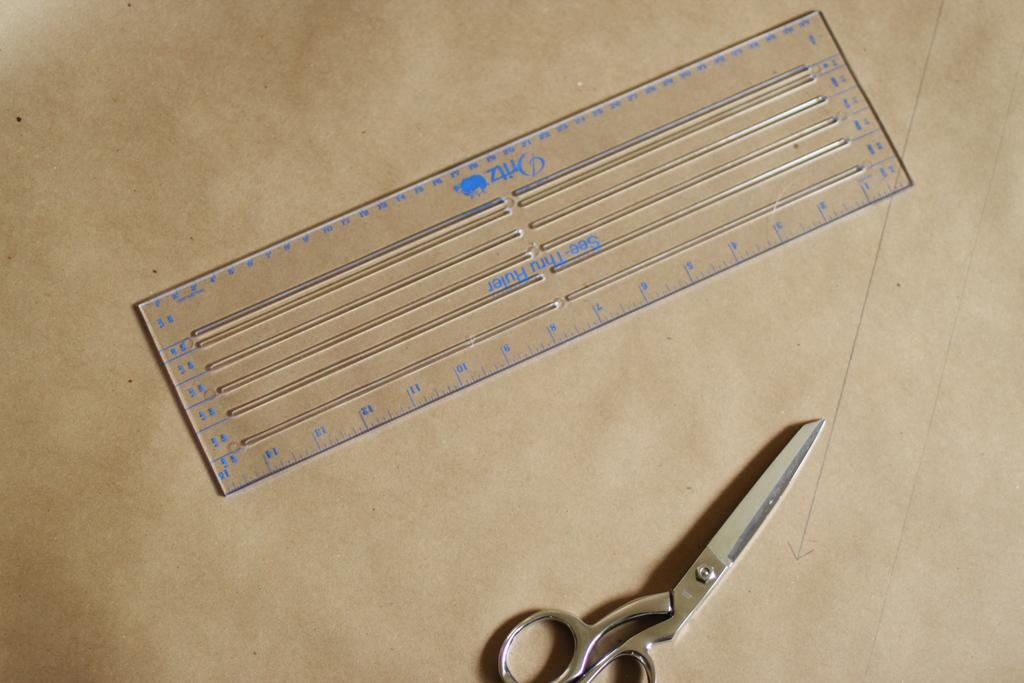Provide a one-sentence caption for the provided image. A "see through ruler" is on the left of metal scissors. 